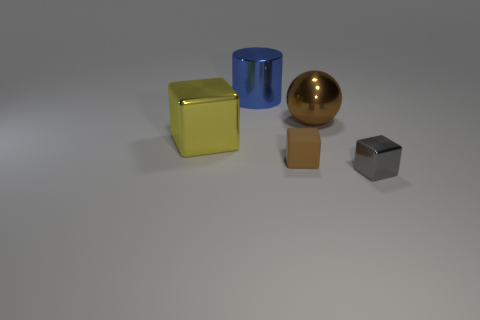Subtract all small brown blocks. How many blocks are left? 2 Subtract all cubes. How many objects are left? 2 Subtract 1 blocks. How many blocks are left? 2 Subtract all yellow blocks. Subtract all blue cylinders. How many blocks are left? 2 Subtract all gray cylinders. How many brown blocks are left? 1 Subtract all large objects. Subtract all yellow cubes. How many objects are left? 1 Add 5 gray cubes. How many gray cubes are left? 6 Add 5 small red matte things. How many small red matte things exist? 5 Add 2 small brown cubes. How many objects exist? 7 Subtract 0 purple spheres. How many objects are left? 5 